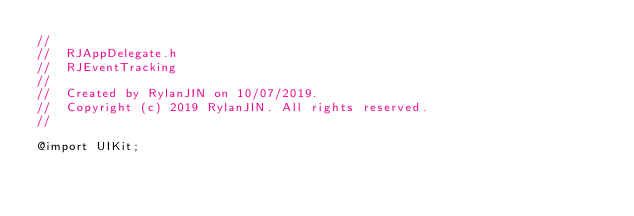<code> <loc_0><loc_0><loc_500><loc_500><_C_>//
//  RJAppDelegate.h
//  RJEventTracking
//
//  Created by RylanJIN on 10/07/2019.
//  Copyright (c) 2019 RylanJIN. All rights reserved.
//

@import UIKit;
</code> 